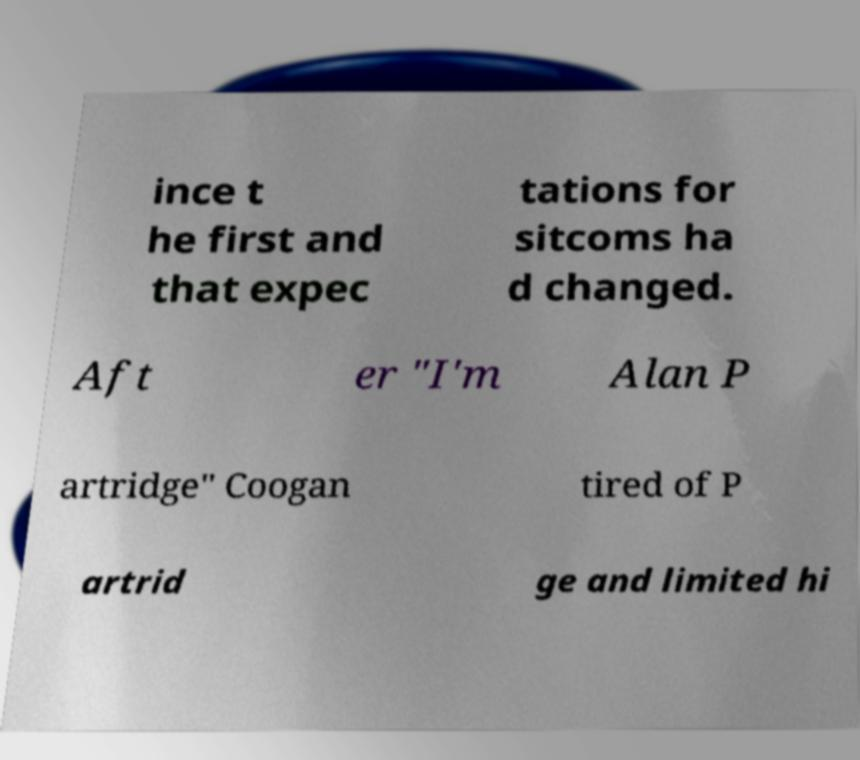There's text embedded in this image that I need extracted. Can you transcribe it verbatim? ince t he first and that expec tations for sitcoms ha d changed. Aft er "I'm Alan P artridge" Coogan tired of P artrid ge and limited hi 